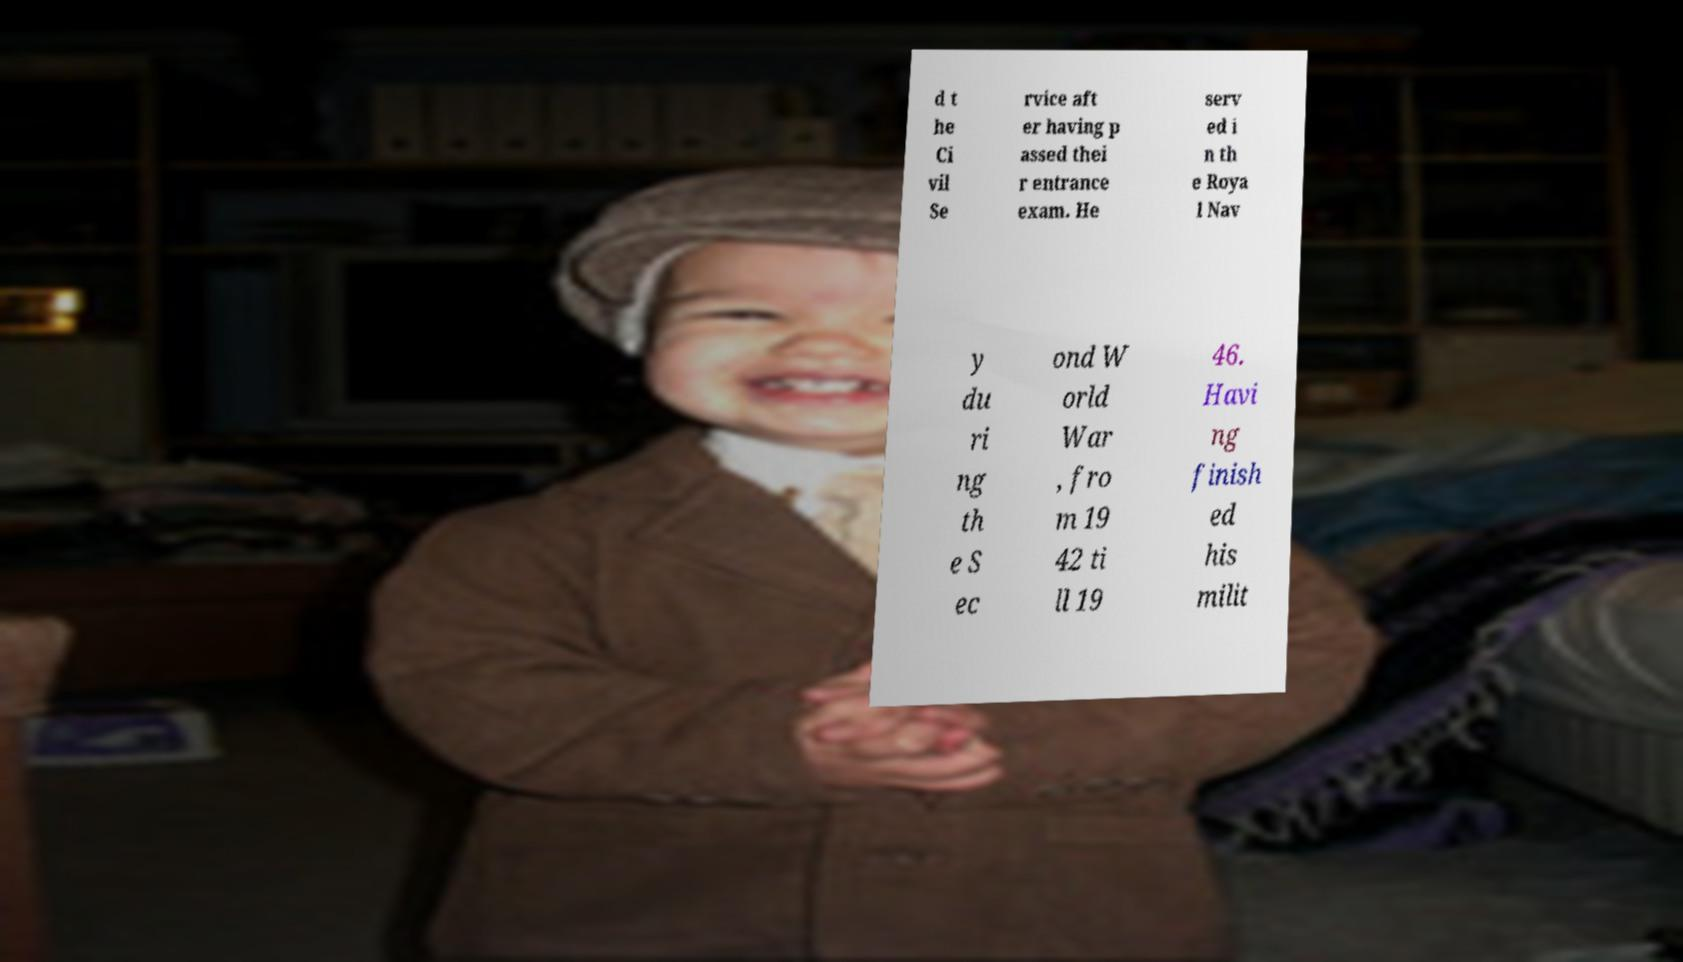There's text embedded in this image that I need extracted. Can you transcribe it verbatim? d t he Ci vil Se rvice aft er having p assed thei r entrance exam. He serv ed i n th e Roya l Nav y du ri ng th e S ec ond W orld War , fro m 19 42 ti ll 19 46. Havi ng finish ed his milit 